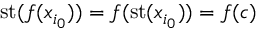Convert formula to latex. <formula><loc_0><loc_0><loc_500><loc_500>{ s t } ( f ( x _ { i _ { 0 } } ) ) = f ( { s t } ( x _ { i _ { 0 } } ) ) = f ( c )</formula> 